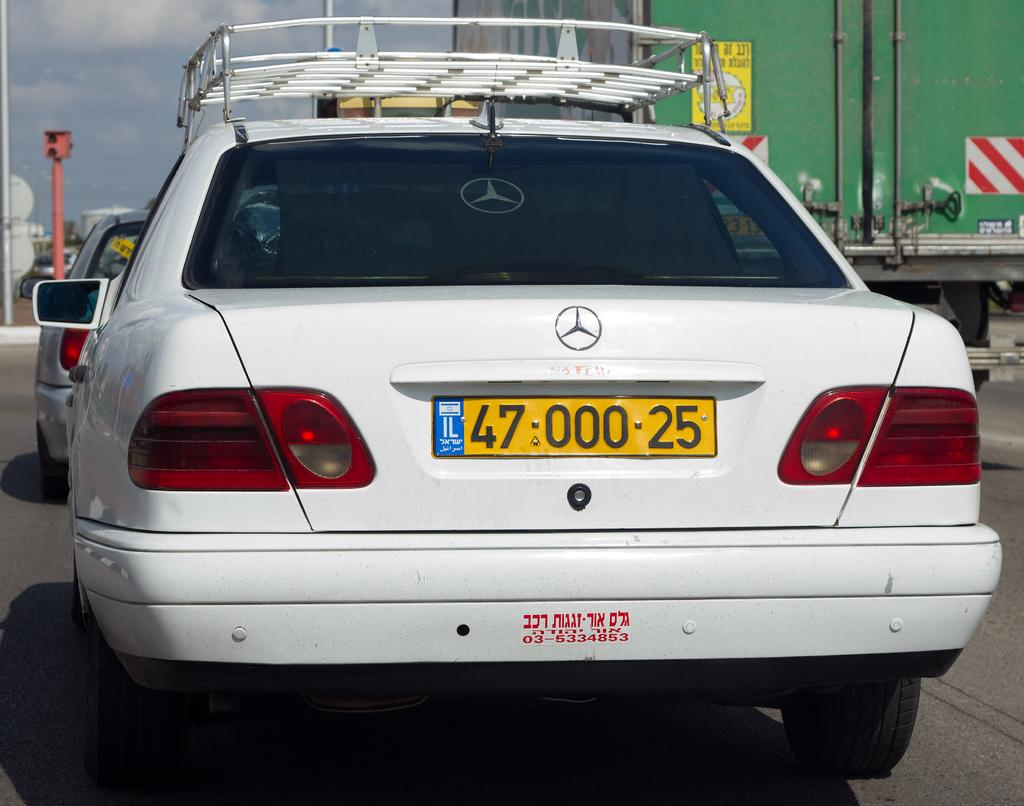What can be seen in the background of the image? The sky is visible in the background of the image. What types of objects are present in the image? There are vehicles and poles in the image. What is the primary surface visible in the image? The road is present at the bottom portion of the image. What word is written on the bucket in the image? There is no bucket present in the image, so it is not possible to answer that question. 